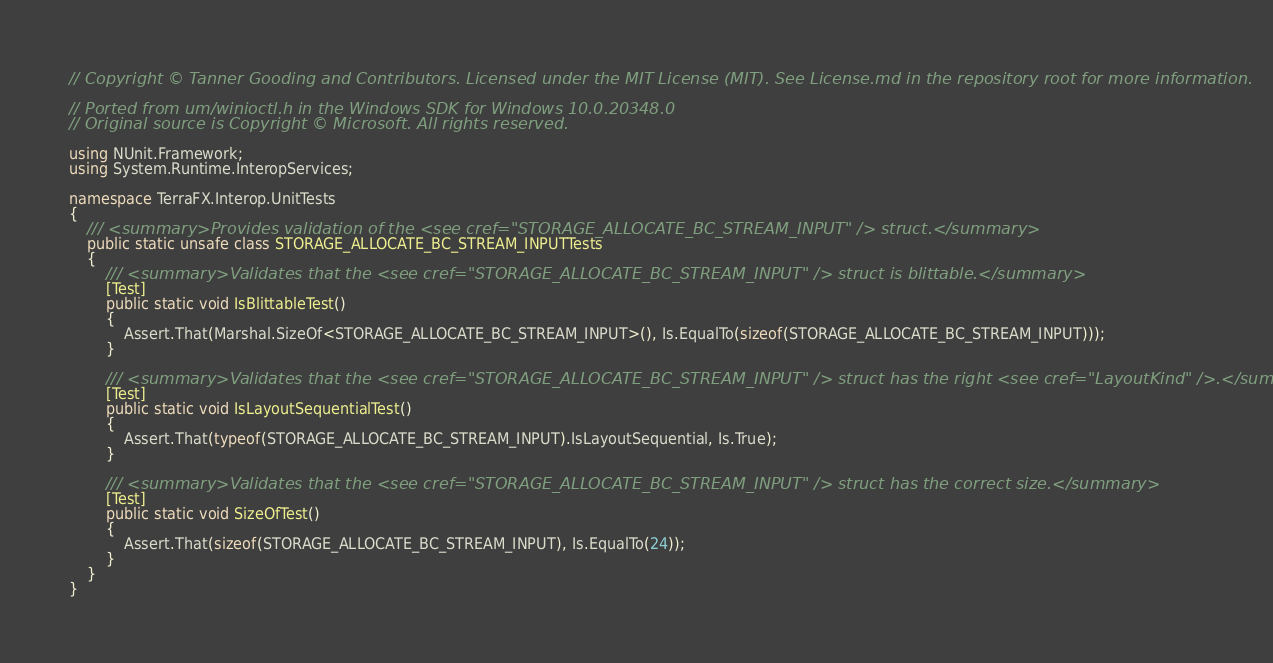Convert code to text. <code><loc_0><loc_0><loc_500><loc_500><_C#_>// Copyright © Tanner Gooding and Contributors. Licensed under the MIT License (MIT). See License.md in the repository root for more information.

// Ported from um/winioctl.h in the Windows SDK for Windows 10.0.20348.0
// Original source is Copyright © Microsoft. All rights reserved.

using NUnit.Framework;
using System.Runtime.InteropServices;

namespace TerraFX.Interop.UnitTests
{
    /// <summary>Provides validation of the <see cref="STORAGE_ALLOCATE_BC_STREAM_INPUT" /> struct.</summary>
    public static unsafe class STORAGE_ALLOCATE_BC_STREAM_INPUTTests
    {
        /// <summary>Validates that the <see cref="STORAGE_ALLOCATE_BC_STREAM_INPUT" /> struct is blittable.</summary>
        [Test]
        public static void IsBlittableTest()
        {
            Assert.That(Marshal.SizeOf<STORAGE_ALLOCATE_BC_STREAM_INPUT>(), Is.EqualTo(sizeof(STORAGE_ALLOCATE_BC_STREAM_INPUT)));
        }

        /// <summary>Validates that the <see cref="STORAGE_ALLOCATE_BC_STREAM_INPUT" /> struct has the right <see cref="LayoutKind" />.</summary>
        [Test]
        public static void IsLayoutSequentialTest()
        {
            Assert.That(typeof(STORAGE_ALLOCATE_BC_STREAM_INPUT).IsLayoutSequential, Is.True);
        }

        /// <summary>Validates that the <see cref="STORAGE_ALLOCATE_BC_STREAM_INPUT" /> struct has the correct size.</summary>
        [Test]
        public static void SizeOfTest()
        {
            Assert.That(sizeof(STORAGE_ALLOCATE_BC_STREAM_INPUT), Is.EqualTo(24));
        }
    }
}
</code> 